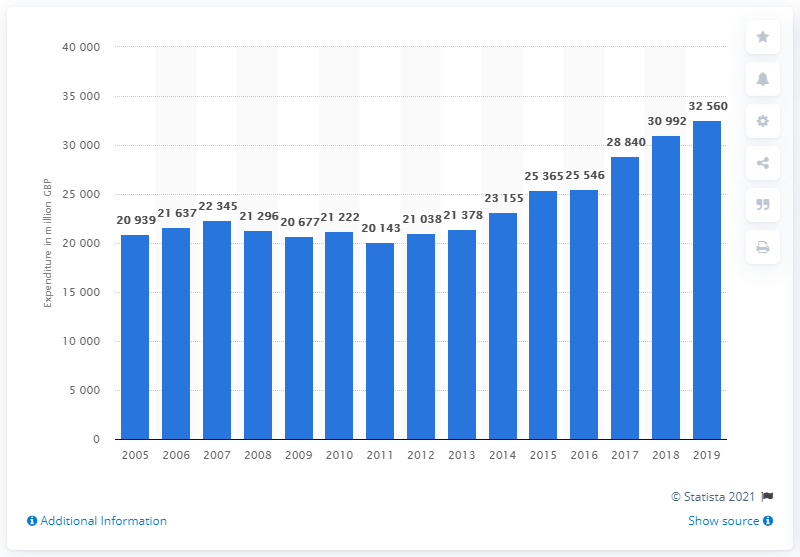Specify some key components in this picture. In the year 2005, personal care expenditure in the UK began. 